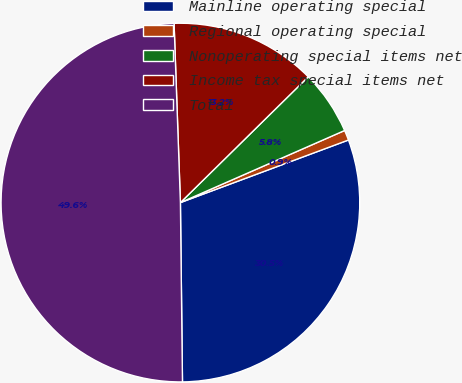<chart> <loc_0><loc_0><loc_500><loc_500><pie_chart><fcel>Mainline operating special<fcel>Regional operating special<fcel>Nonoperating special items net<fcel>Income tax special items net<fcel>Total<nl><fcel>30.49%<fcel>0.91%<fcel>5.79%<fcel>13.19%<fcel>49.62%<nl></chart> 